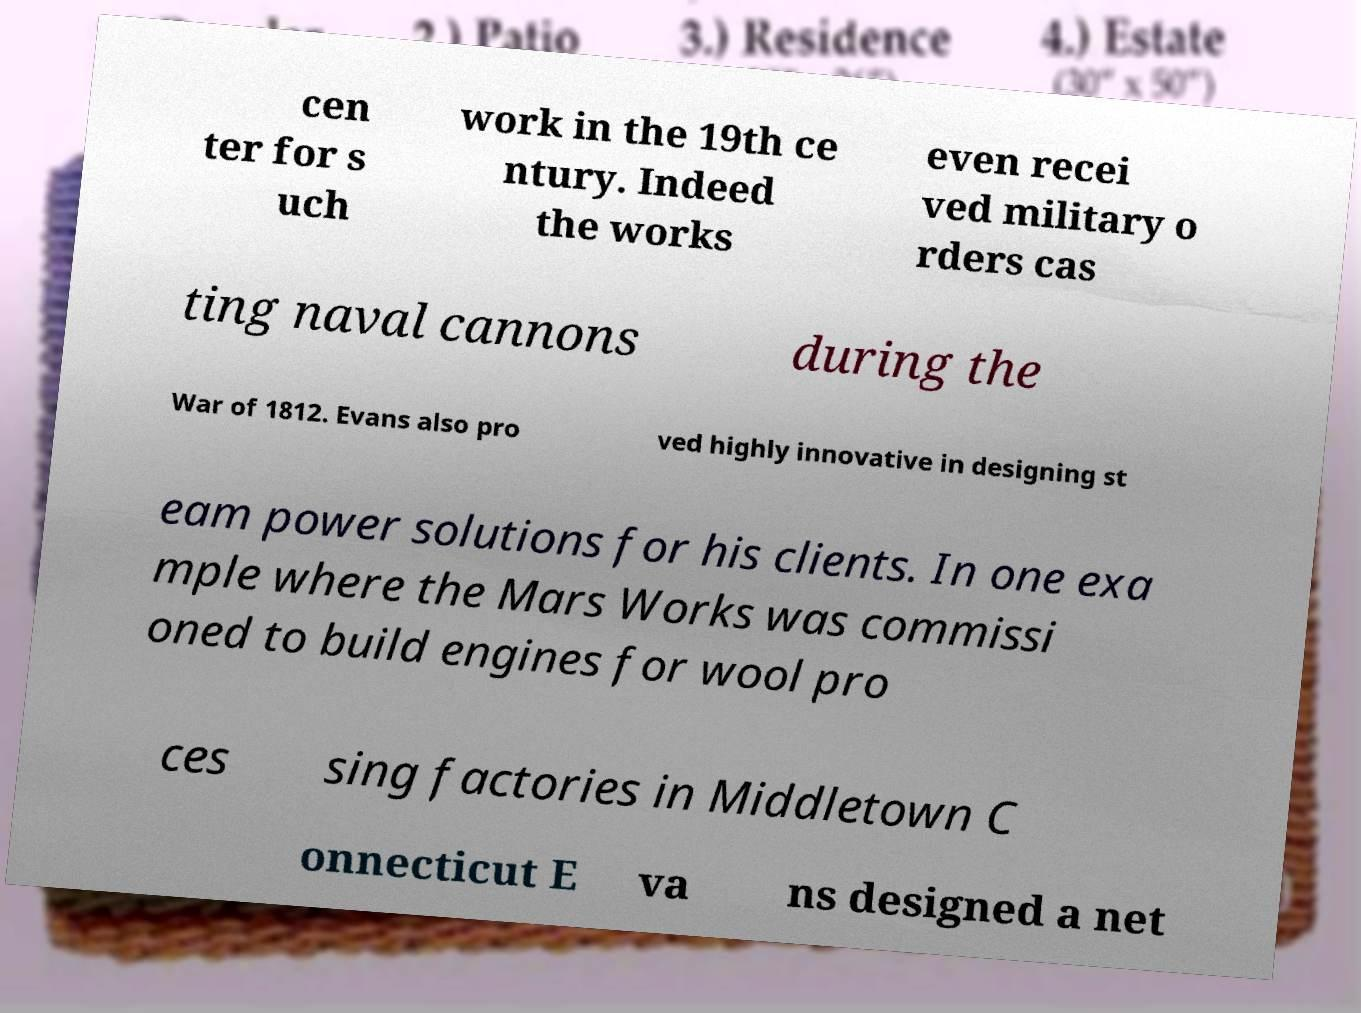For documentation purposes, I need the text within this image transcribed. Could you provide that? cen ter for s uch work in the 19th ce ntury. Indeed the works even recei ved military o rders cas ting naval cannons during the  War of 1812. Evans also pro ved highly innovative in designing st eam power solutions for his clients. In one exa mple where the Mars Works was commissi oned to build engines for wool pro ces sing factories in Middletown C onnecticut E va ns designed a net 